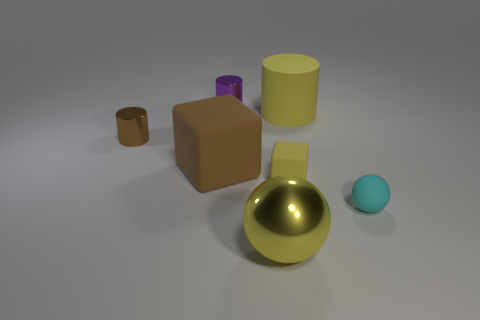There is a large rubber thing that is the same color as the big metal object; what is its shape?
Provide a succinct answer. Cylinder. What color is the big block in front of the big yellow object that is behind the yellow cube?
Your answer should be very brief. Brown. There is another big object that is the same shape as the brown shiny thing; what is its color?
Ensure brevity in your answer.  Yellow. The cyan matte thing that is the same shape as the large metal thing is what size?
Provide a succinct answer. Small. There is a ball that is to the right of the big yellow metallic ball; what is it made of?
Offer a terse response. Rubber. Is the number of tiny rubber balls that are in front of the yellow ball less than the number of tiny cubes?
Ensure brevity in your answer.  Yes. What is the shape of the large rubber thing that is right of the metallic object in front of the yellow matte block?
Your response must be concise. Cylinder. The large ball is what color?
Ensure brevity in your answer.  Yellow. What number of other things are there of the same size as the brown metallic thing?
Provide a succinct answer. 3. What is the cylinder that is both in front of the purple metal cylinder and right of the big matte block made of?
Offer a terse response. Rubber. 